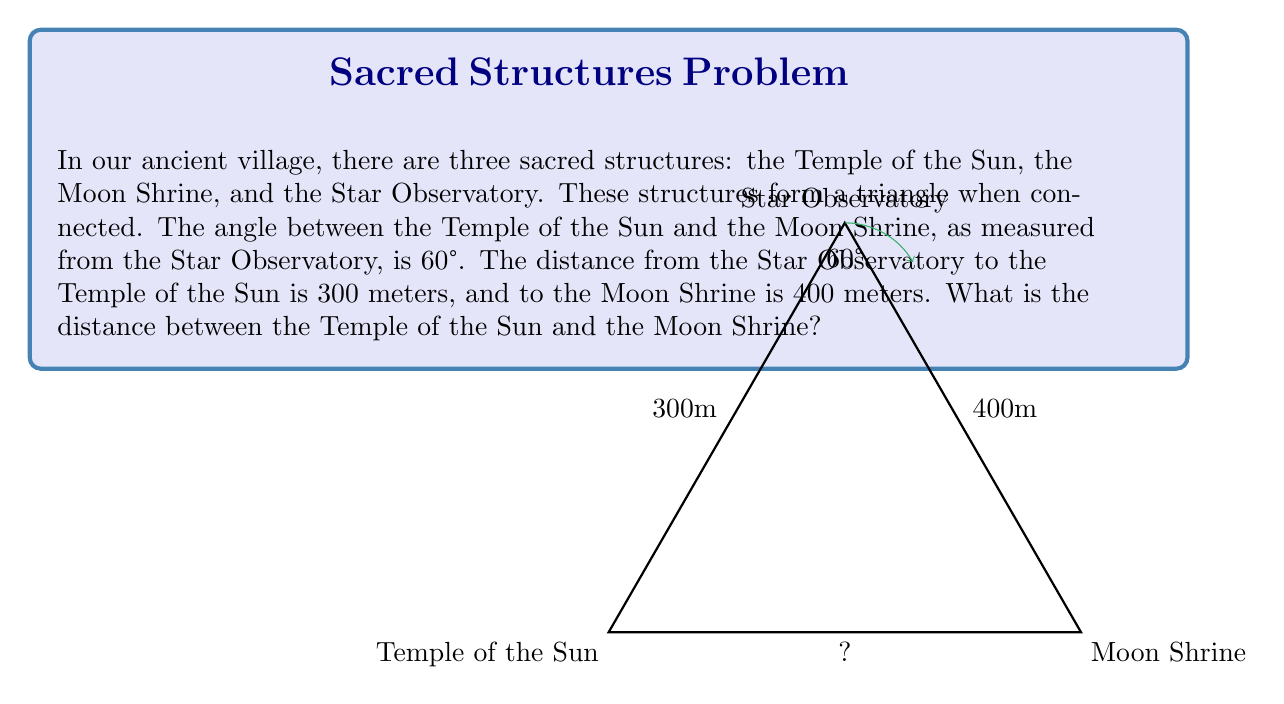Can you answer this question? To solve this problem, we can use the law of cosines. The law of cosines states that for a triangle with sides a, b, and c, and an angle C opposite the side c:

$$ c^2 = a^2 + b^2 - 2ab \cos(C) $$

In our case:
- a = 300 meters (distance from Star Observatory to Temple of the Sun)
- b = 400 meters (distance from Star Observatory to Moon Shrine)
- C = 60° (angle at Star Observatory)
- c = the distance we're trying to find (between Temple of the Sun and Moon Shrine)

Let's plug these values into the formula:

$$ c^2 = 300^2 + 400^2 - 2(300)(400) \cos(60°) $$

Now, let's solve step by step:

1) First, calculate the squares:
   $$ c^2 = 90,000 + 160,000 - 2(300)(400) \cos(60°) $$

2) Simplify:
   $$ c^2 = 250,000 - 240,000 \cos(60°) $$

3) We know that $\cos(60°) = \frac{1}{2}$, so:
   $$ c^2 = 250,000 - 240,000 (\frac{1}{2}) $$

4) Simplify:
   $$ c^2 = 250,000 - 120,000 = 130,000 $$

5) Take the square root of both sides:
   $$ c = \sqrt{130,000} $$

6) Simplify the square root:
   $$ c = 10\sqrt{1,300} \approx 360.56 $$

Therefore, the distance between the Temple of the Sun and the Moon Shrine is approximately 360.56 meters.
Answer: $10\sqrt{1,300}$ meters 